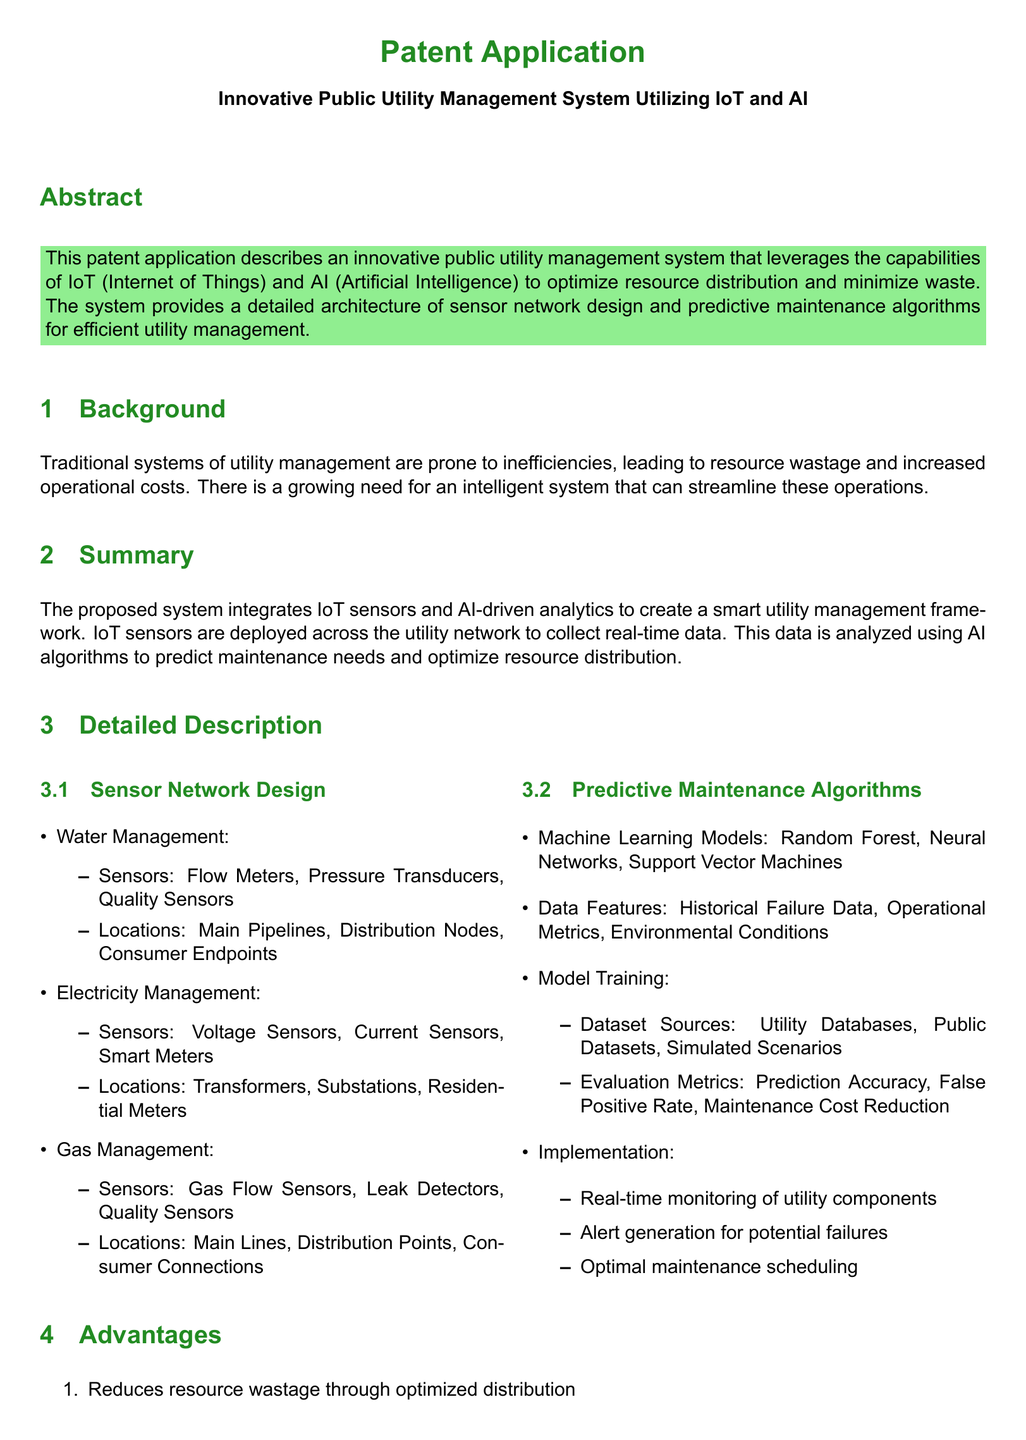What is the main focus of the patent application? The main focus of the patent application is described in the abstract, highlighting the innovative public utility management system.
Answer: Innovative public utility management system utilizing IoT and AI How many types of management are mentioned in the sensor network design? The sensor network design section lists three types of management systems: water, electricity, and gas.
Answer: Three What type of sensors is used in electricity management? The document lists specific sensors for electricity management that include voltage sensors, current sensors, and smart meters.
Answer: Voltage Sensors, Current Sensors, Smart Meters What is one machine learning model mentioned for predictive maintenance? The section on predictive maintenance algorithms lists several machine learning models, including Random Forest.
Answer: Random Forest Which section outlines the advantages of the proposed system? The advantages of the proposed system are detailed in their own section, which specifically lists the benefits.
Answer: Advantages What is the purpose of real-time monitoring in the proposed system? The detailed description of predictive maintenance algorithms states that real-time monitoring is for monitoring of utility components.
Answer: Monitoring of utility components What are two data features used in the predictive maintenance algorithms? The document specifies historical failure data and operational metrics as data features used in the predictive maintenance algorithms.
Answer: Historical Failure Data, Operational Metrics How many claims are made in this patent application? The claims section states the number of claims present in this document.
Answer: Three 